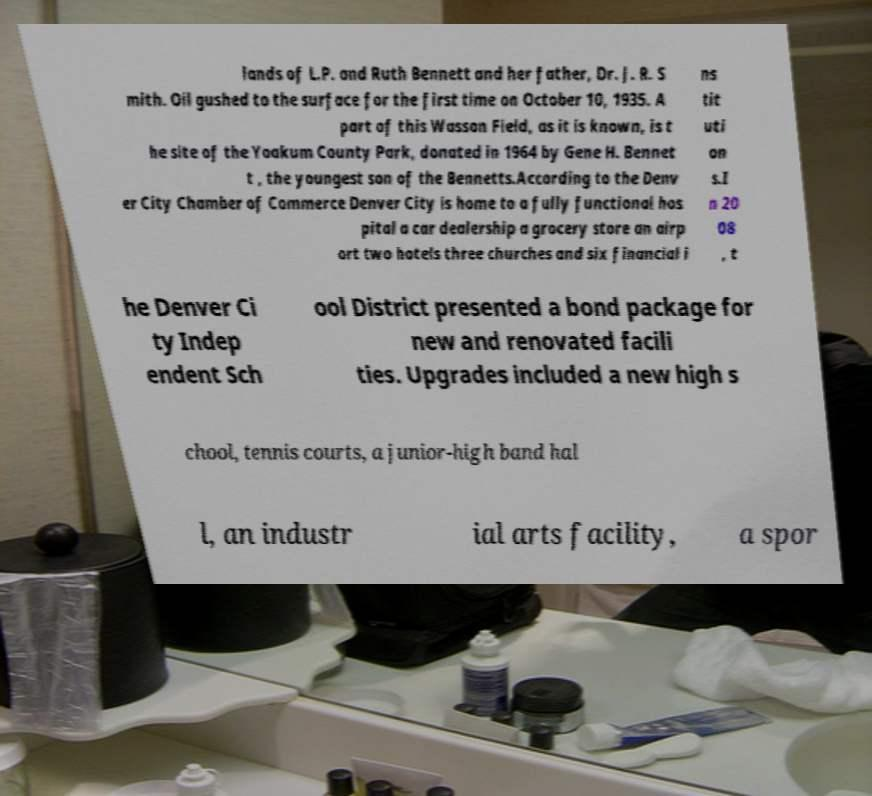What messages or text are displayed in this image? I need them in a readable, typed format. lands of L.P. and Ruth Bennett and her father, Dr. J. R. S mith. Oil gushed to the surface for the first time on October 10, 1935. A part of this Wasson Field, as it is known, is t he site of the Yoakum County Park, donated in 1964 by Gene H. Bennet t , the youngest son of the Bennetts.According to the Denv er City Chamber of Commerce Denver City is home to a fully functional hos pital a car dealership a grocery store an airp ort two hotels three churches and six financial i ns tit uti on s.I n 20 08 , t he Denver Ci ty Indep endent Sch ool District presented a bond package for new and renovated facili ties. Upgrades included a new high s chool, tennis courts, a junior-high band hal l, an industr ial arts facility, a spor 